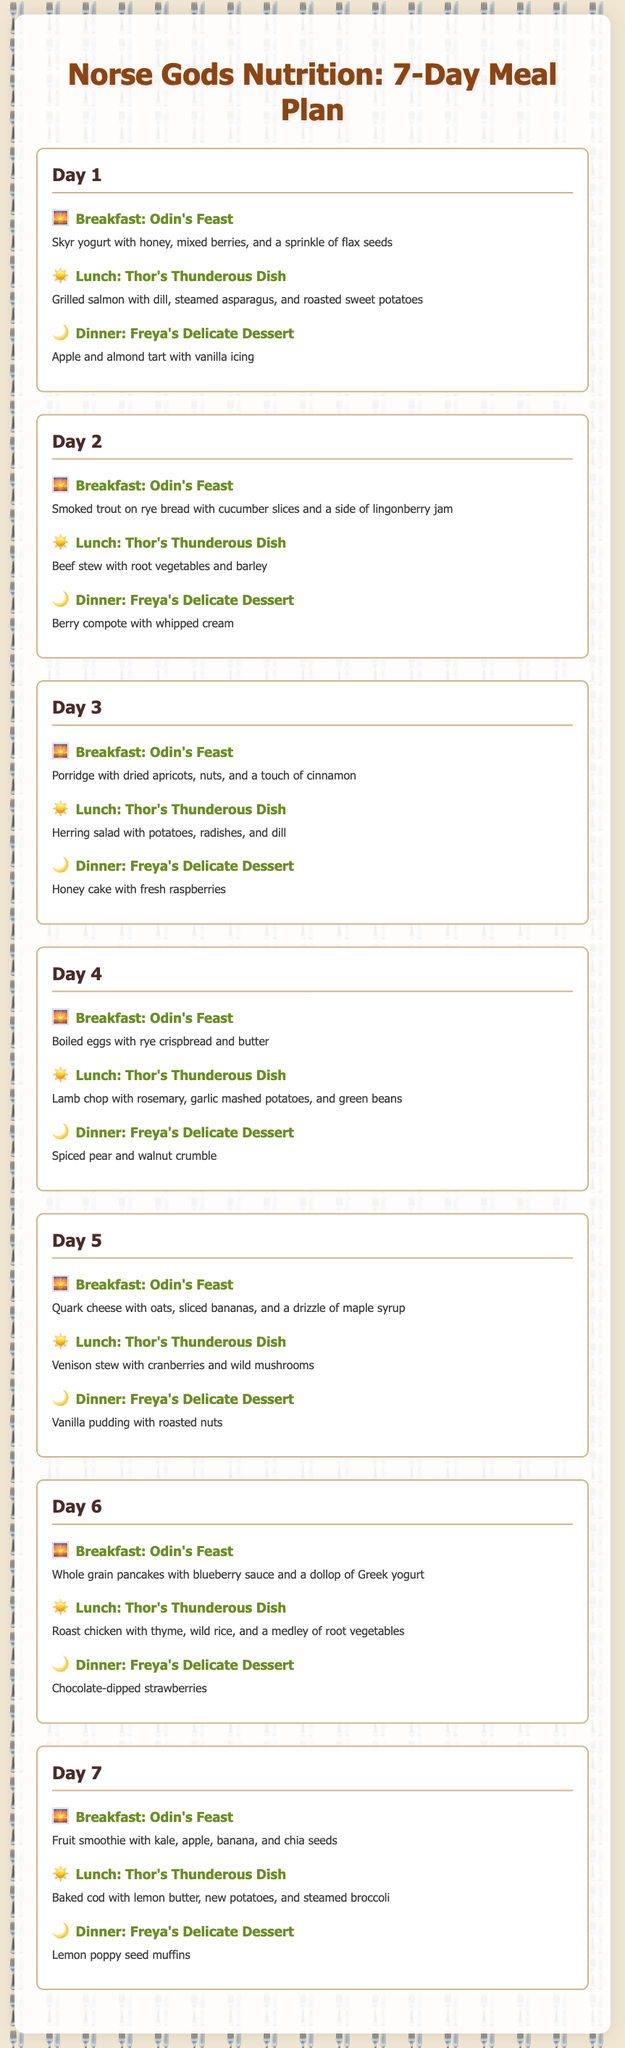What is the first meal on Day 1? The first meal listed on Day 1 is "Odin's Feast," which includes skyr yogurt with honey, mixed berries, and a sprinkle of flax seeds.
Answer: Odin's Feast What is served for lunch on Day 3? The lunch for Day 3 is "Thor's Thunderous Dish," featuring herring salad with potatoes, radishes, and dill.
Answer: Herring salad with potatoes, radishes, and dill How many days does the meal plan cover? The meal plan is structured to provide meals for a total of 7 days.
Answer: 7 days What type of dessert is served on Day 5? The dessert for Day 5 is "Freya's Delicate Dessert," which is vanilla pudding with roasted nuts.
Answer: Vanilla pudding with roasted nuts On which day is roasted sweet potatoes served? Roasted sweet potatoes are served on Day 1 during lunch with grilled salmon and asparagus.
Answer: Day 1 Which meal features chocolate-dipped strawberries? "Freya's Delicate Dessert" on Day 6 features chocolate-dipped strawberries.
Answer: Chocolate-dipped strawberries What is a common feature of Odin's Feast throughout the week? Odin's Feast often includes healthy options like yogurt, fruits, or grains.
Answer: Healthy options How many Thor's Thunderous Dishes include meat? There are 5 Thor's Thunderous Dishes during the week that include meat: salmon, beef, lamb, venison, and chicken.
Answer: 5 